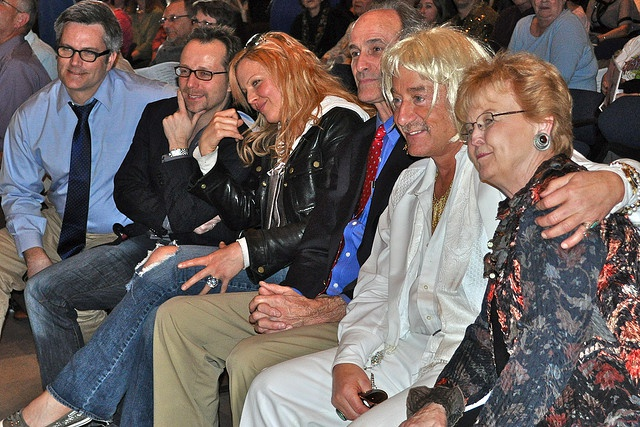Describe the objects in this image and their specific colors. I can see people in maroon, gray, black, and tan tones, people in maroon, lightgray, darkgray, brown, and tan tones, people in maroon, black, gray, blue, and brown tones, people in maroon, gray, and black tones, and people in maroon, darkgray, black, and gray tones in this image. 